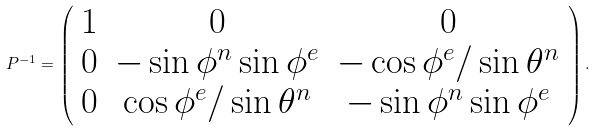Convert formula to latex. <formula><loc_0><loc_0><loc_500><loc_500>P ^ { - 1 } = \left ( \begin{array} { c c c } 1 & 0 & 0 \\ 0 & - \sin { \phi ^ { n } } \sin { \phi ^ { e } } & - \cos { \phi ^ { e } } / \sin { \theta ^ { n } } \\ 0 & \cos { \phi ^ { e } } / \sin { \theta ^ { n } } & - \sin { \phi ^ { n } } \sin { \phi ^ { e } } \end{array} \right ) .</formula> 